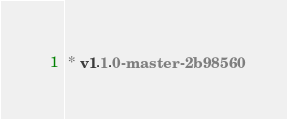<code> <loc_0><loc_0><loc_500><loc_500><_CSS_> * v1.1.0-master-2b98560</code> 